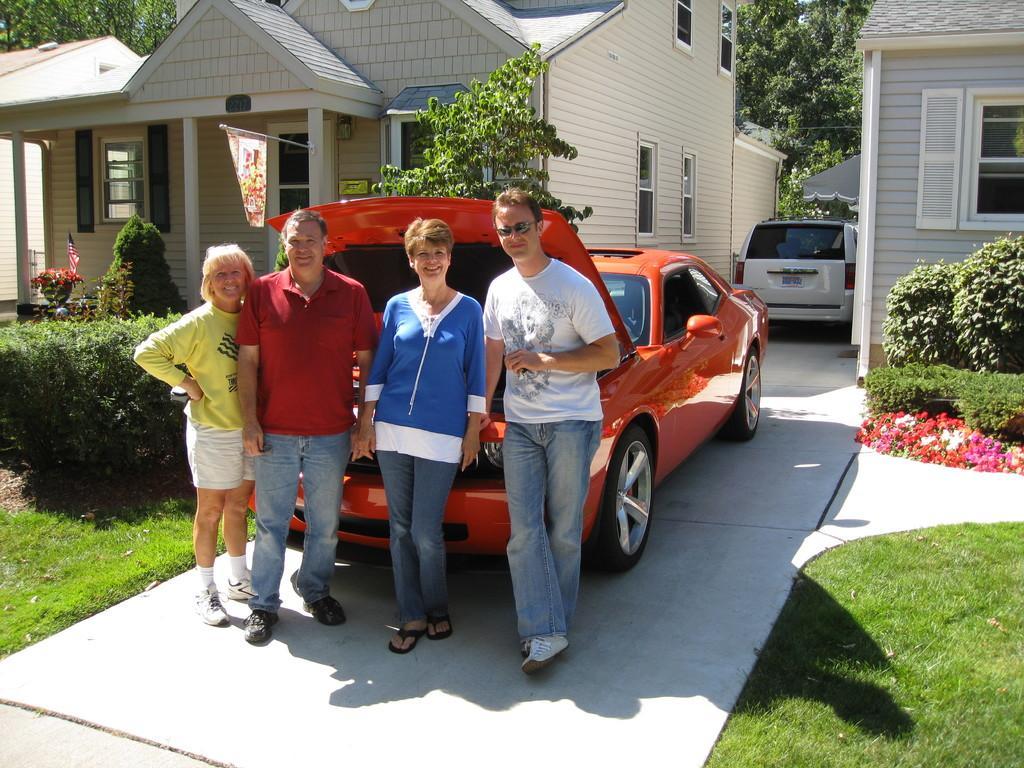Can you describe this image briefly? In the background we can see the houses, windows, flag, white car, awning, trees. In this picture we can see the plants, green grass, flowers and we can see the people standing near to a car. They all are smiling. 